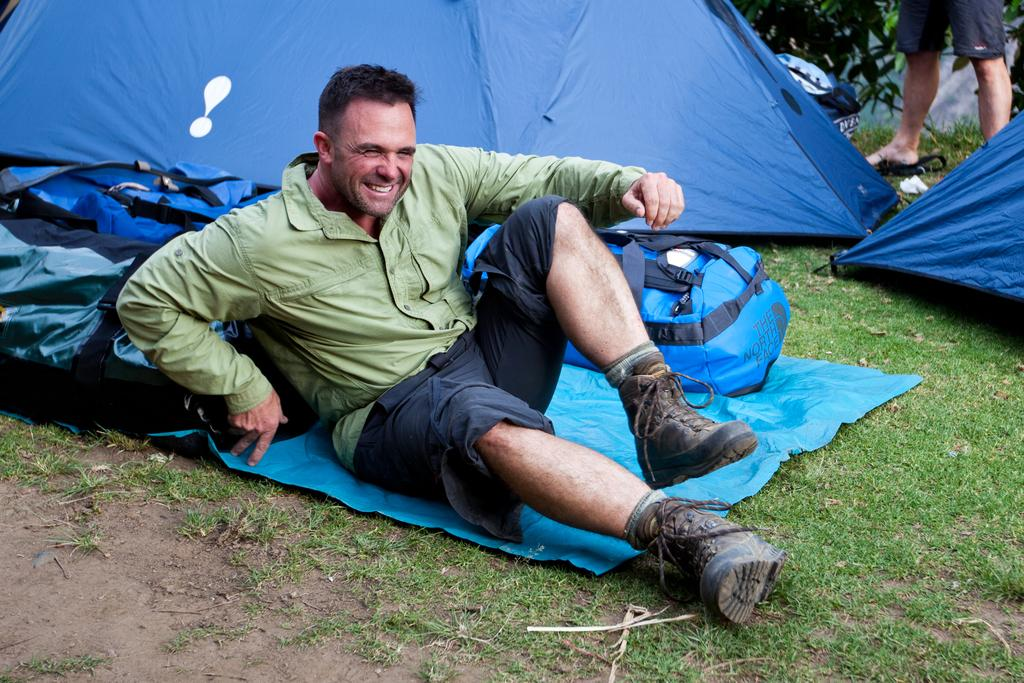What type of landscape is depicted in the image? There is a grassland in the image. What is the man in the image doing? The man is sitting on a mat on the grassland. What can be seen in the background of the image? There are bags and tents in the background of the image. Can you describe the person in the top right corner of the image? There is a person standing in the top right corner of the image. What type of self-exchange is taking place between the man and the monkey in the image? There is no monkey present in the image, and therefore no self-exchange can be observed. 